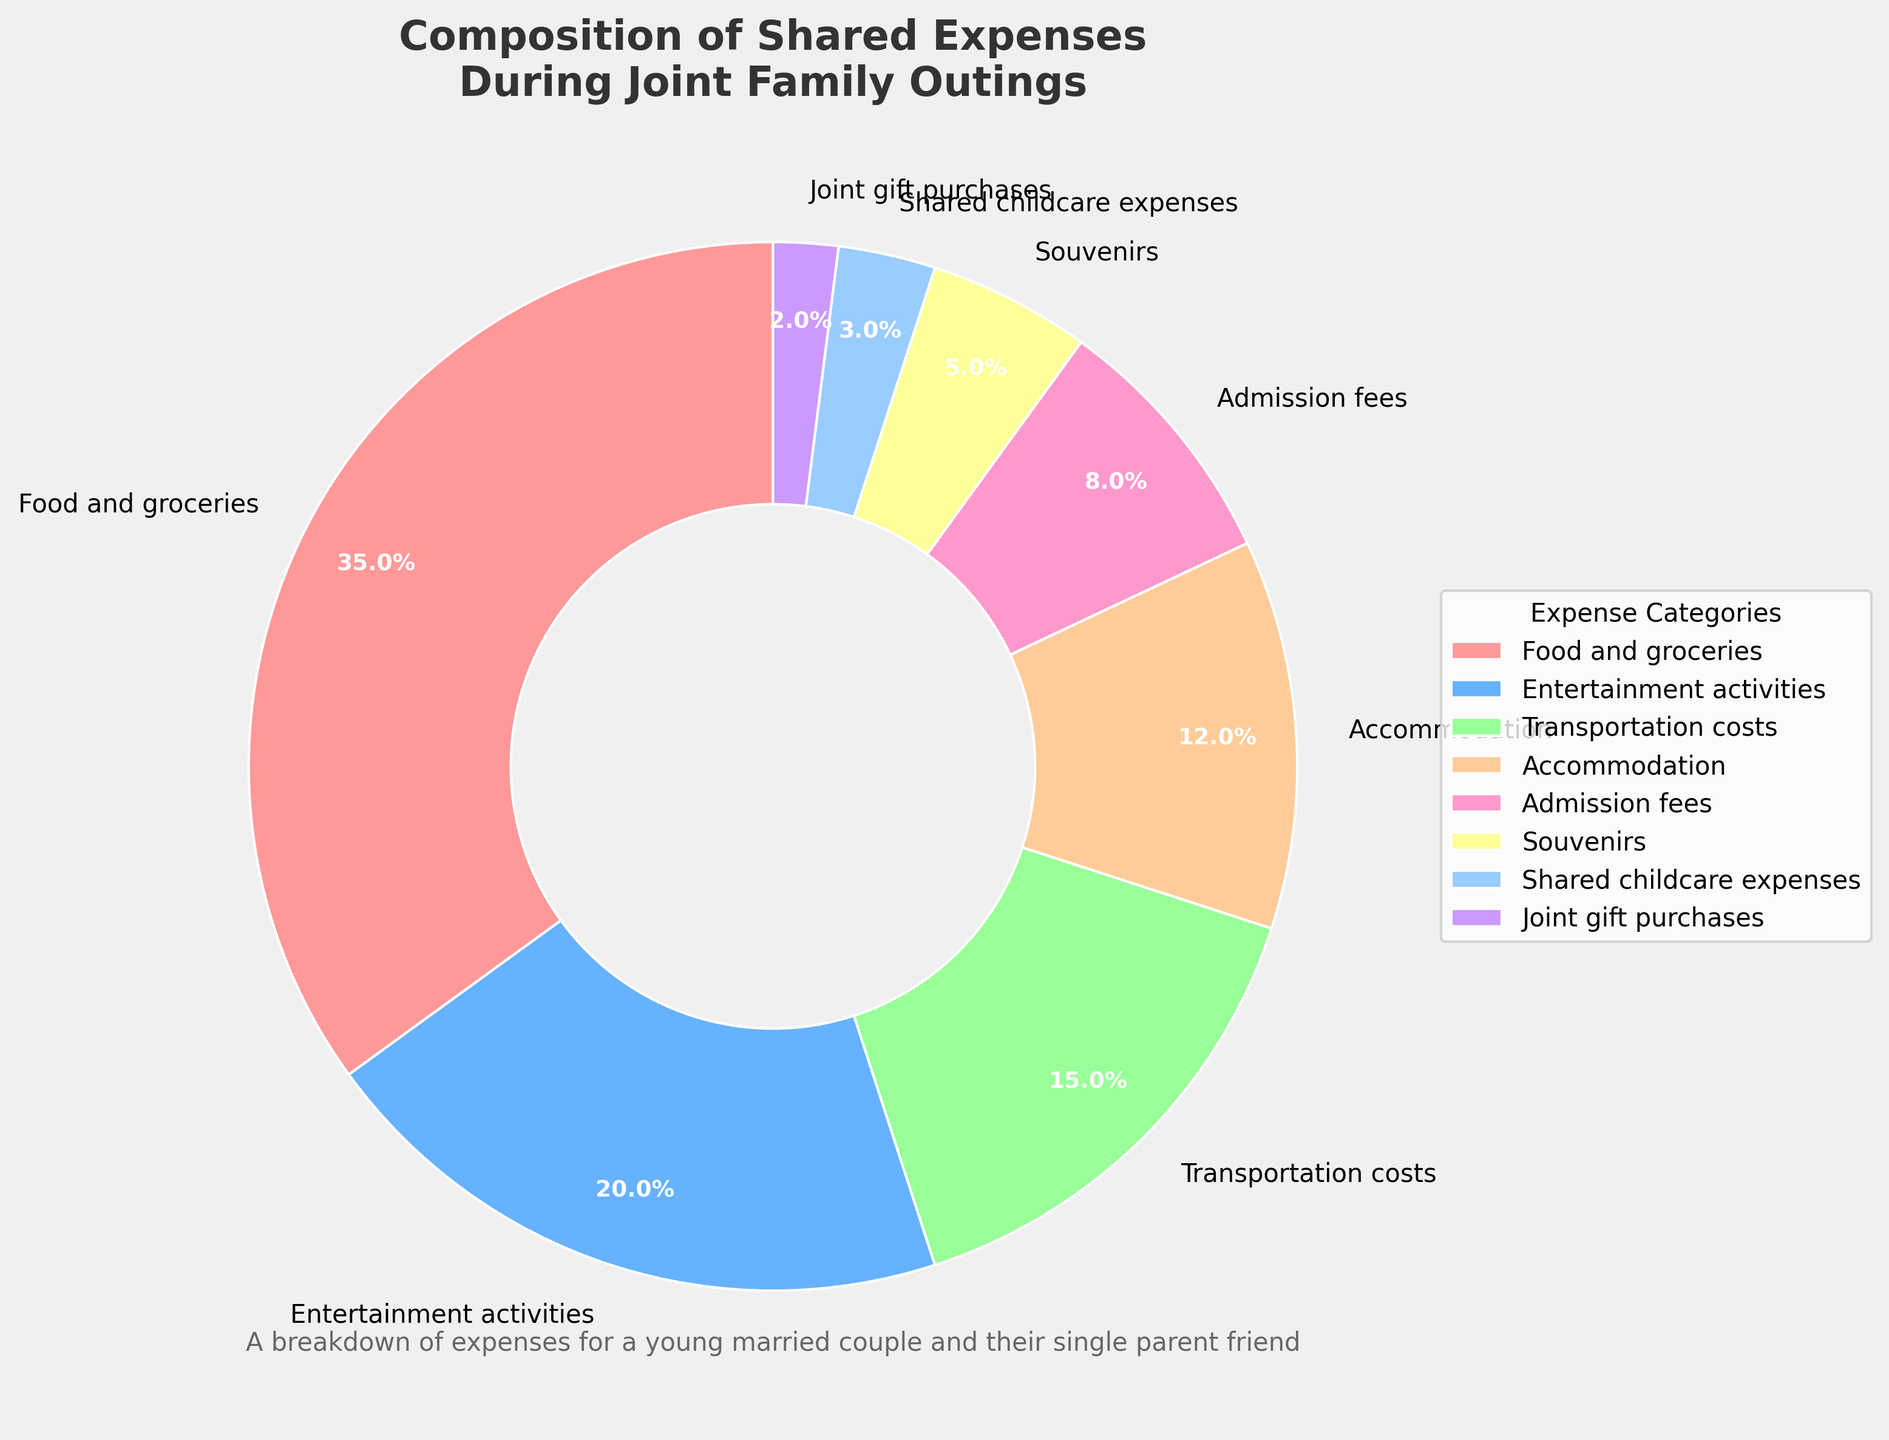What percentage of shared expenses goes towards food and groceries? From the pie chart, we locate the segment labeled "Food and groceries." This segment shows the percentage of expenses allocated to this category.
Answer: 35% How much more do we spend on food and groceries compared to transportation costs? From the figure, the percentage for food and groceries is 35%, and for transportation costs, it is 15%. The difference between these two is calculated as 35% - 15%.
Answer: 20% Which category has the smallest percentage of shared expenses? By examining the slices of the pie, the smallest segment is labeled as "Joint gift purchases" with a percentage of 2%.
Answer: Joint gift purchases What percentage of expenses is dedicated to accommodation and admission fees combined? From the pie chart, accommodation is 12% and admission fees are 8%. Adding these together gives 12% + 8%.
Answer: 20% Is the percentage spent on entertainment activities greater than the percentage spent on transportation costs? According to the pie chart, entertainment activities account for 20%, and transportation costs are 15%. Since 20% is greater than 15%, the answer is yes.
Answer: Yes If we combine the percentages for shared childcare expenses and joint gift purchases, do they exceed the percentage for souvenirs? Shared childcare expenses are 3%, and joint gift purchases are 2%. Together, they amount to 3% + 2% = 5%, which is equal to the percentage for souvenirs (also 5%). Therefore, they do not exceed it.
Answer: No What is the largest category of expenses after food and groceries? The largest slice after "Food and groceries" (35%) is "Entertainment activities," which is 20%.
Answer: Entertainment activities Which two categories make up exactly 23% of the shared expenses? We need to look at combinations of categories adding up to 23%. The segments "Accommodation" (12%) and "Shared childcare expenses" (3%) combine to add up to 23%. Another combination is "Admission fees" (8%) and "Souvenirs" (5%), but they sum to 13%. Therefore, the two categories that add up to 23% are "Accommodation" and "Shared childcare expenses".
Answer: Accommodation and Shared childcare expenses Between food and groceries and entertainment activities, which has the larger share of the expenses, and by what percentage point difference? The pie chart shows food and groceries at 35% and entertainment activities at 20%. The difference between them is 35% - 20%.
Answer: Food and groceries, 15% What is the combined percentage of expenses excluding food and groceries? To find the combined percentage excluding food and groceries, add the percentages of all other categories: 20% (Entertainment activities) + 15% (Transportation costs) + 12% (Accommodation) + 8% (Admission fees) + 5% (Souvenirs) + 3% (Shared childcare expenses) + 2% (Joint gift purchases). The total is 65%.
Answer: 65% 